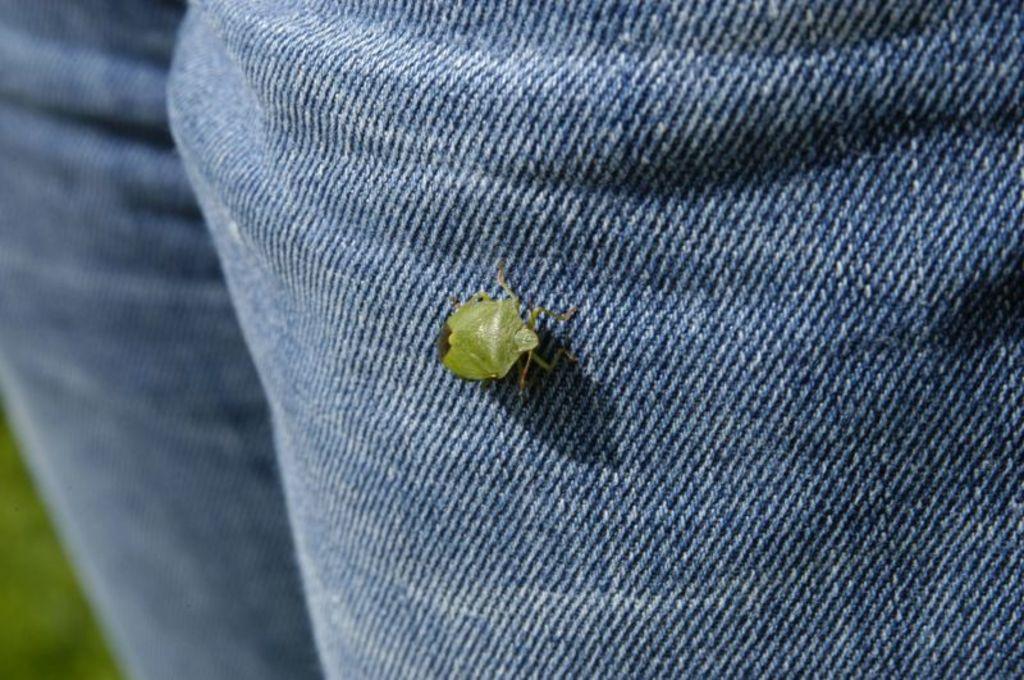How would you summarize this image in a sentence or two? In this picture we can see a bug on a cloth. At the bottom left corner of the image, it is blurred. 